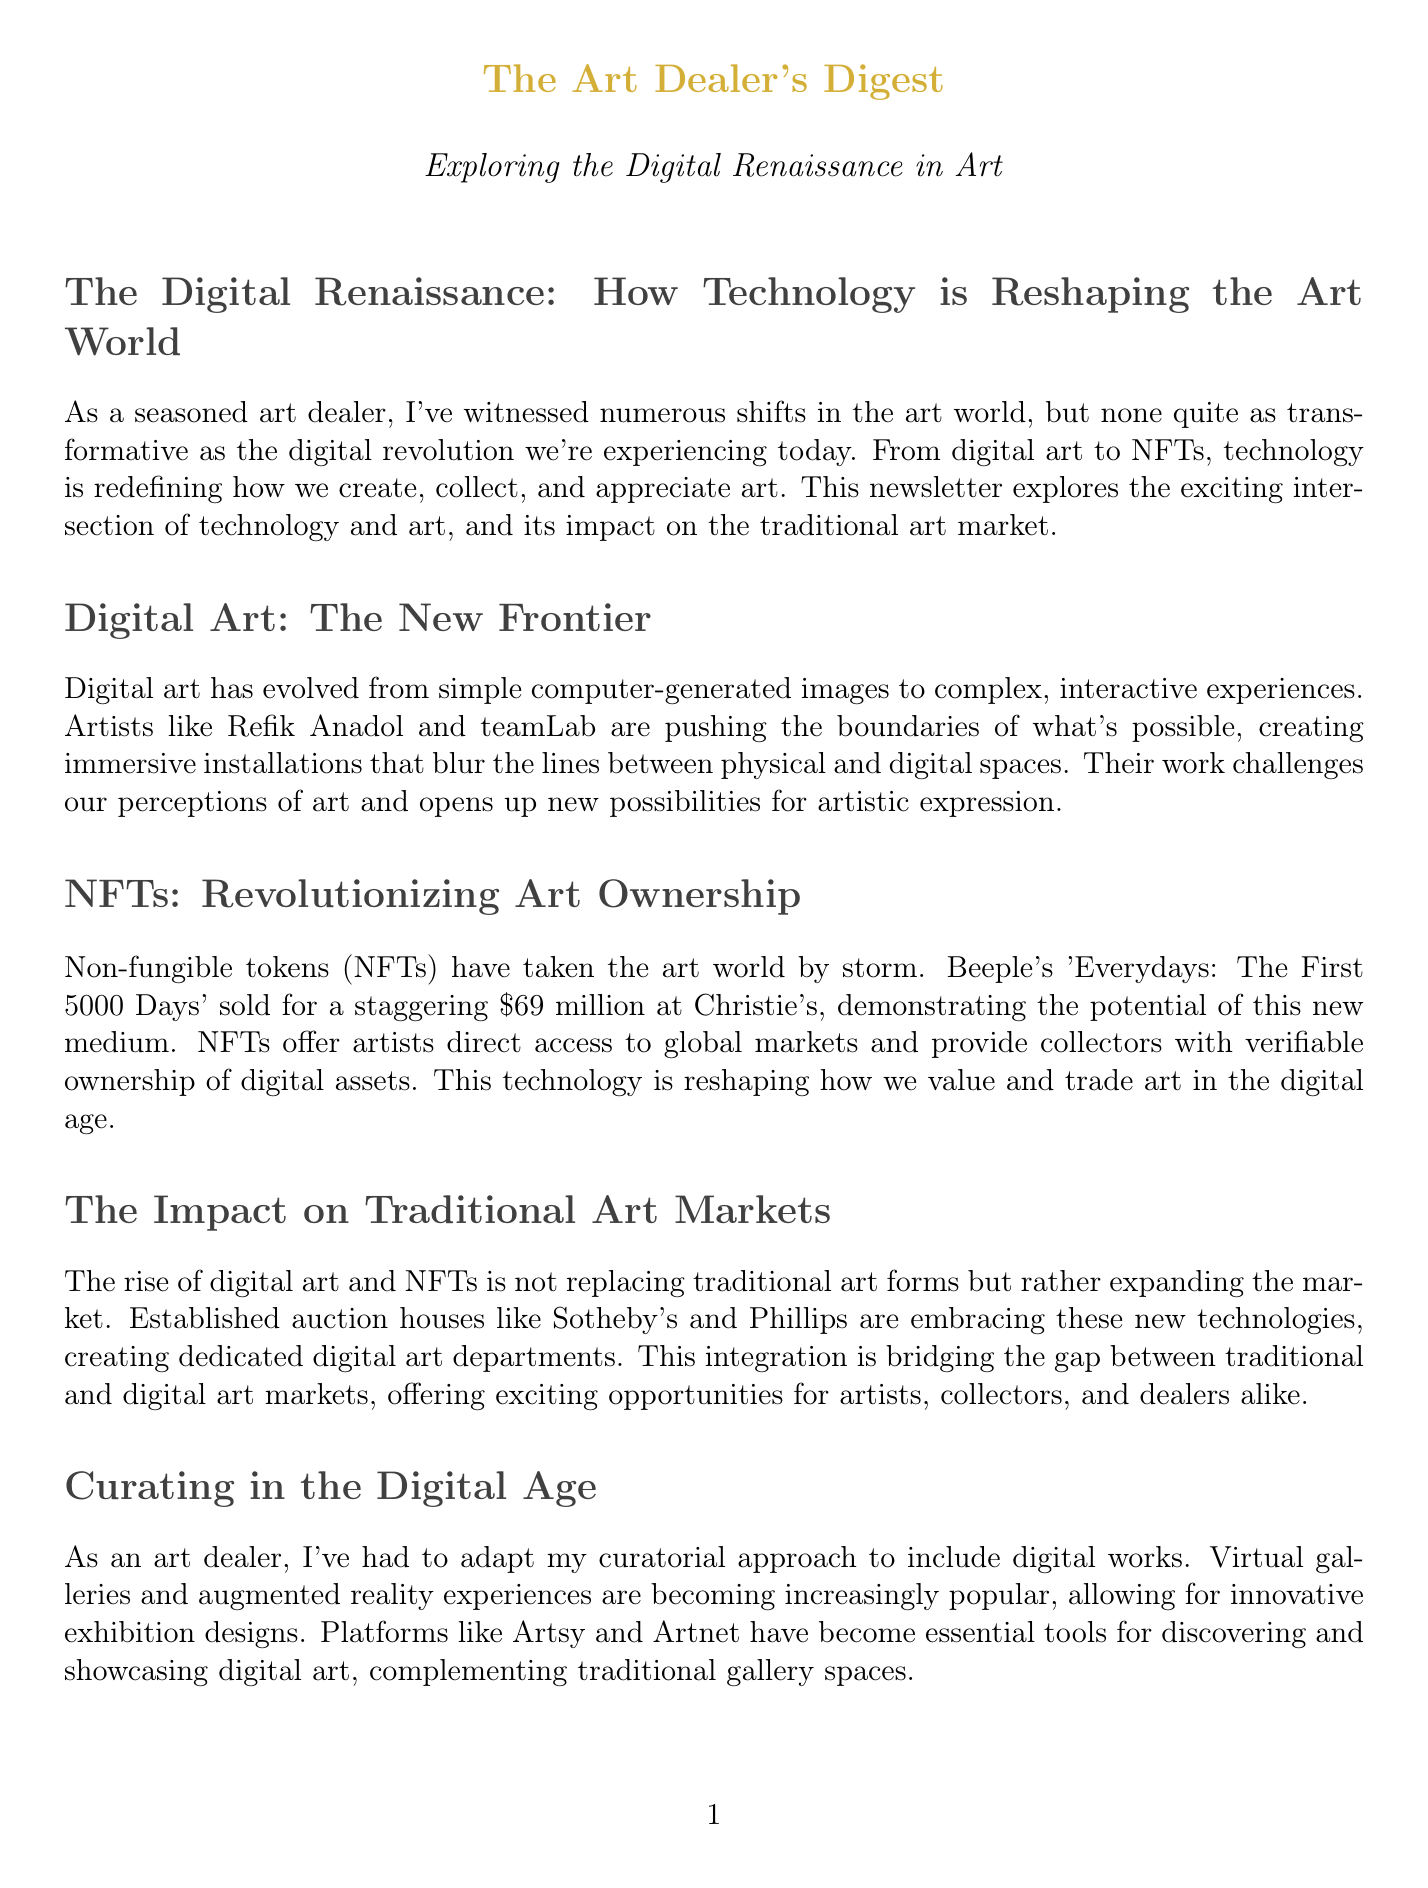What is the title of the newsletter? The title encompasses the focus of the newsletter which is on technology and art.
Answer: The Art Dealer's Digest Who sold 'Everydays: The First 5000 Days'? This refers to a specific artist highlighted in the document concerning NFTs.
Answer: Beeple How much did Beeple's artwork sell for? This is a specific amount mentioned in the section about NFTs.
Answer: $69 million Which two artists are mentioned in the Digital Art section? This requires identifying artists discussed in relation to their contributions to digital art.
Answer: Refik Anadol and teamLab What technology is used for provenance tracking in digital art preservation? The document mentions a specific technology related to tracking ownership of digital art.
Answer: Blockchain What are Artsy and Artnet used for? This question pertains to platforms mentioned in the curatorial approach section of the newsletter.
Answer: Discovering and showcasing digital art Which art institutions are developing strategies for digital artwork preservation? This identifies the institution highlighted in the context of art conservation.
Answer: Museum of Modern Art (MoMA) What is the focus of the newsletter's conclusion? This refers to the overarching message conveyed in the conclusion of the document.
Answer: Embracing the Digital Art Revolution 